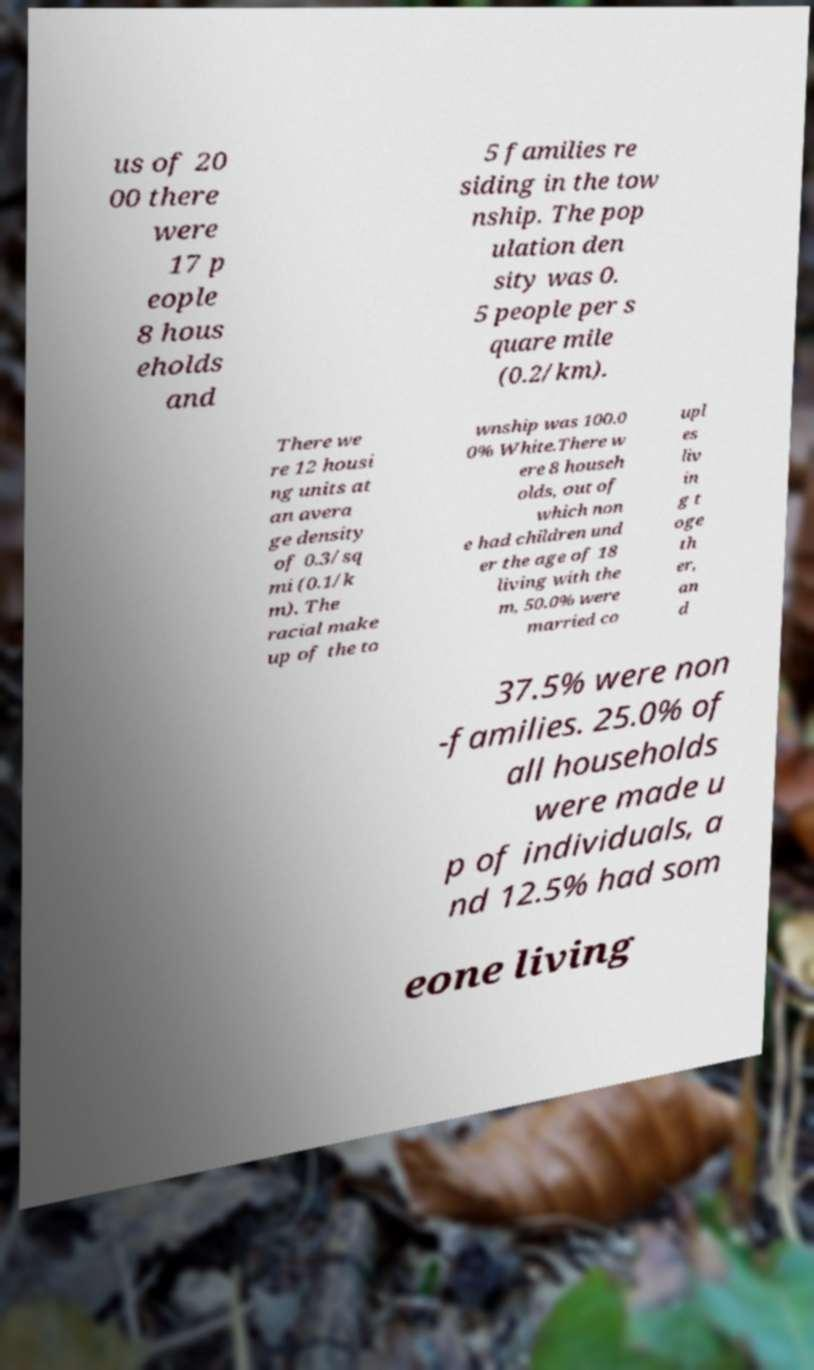Please read and relay the text visible in this image. What does it say? us of 20 00 there were 17 p eople 8 hous eholds and 5 families re siding in the tow nship. The pop ulation den sity was 0. 5 people per s quare mile (0.2/km). There we re 12 housi ng units at an avera ge density of 0.3/sq mi (0.1/k m). The racial make up of the to wnship was 100.0 0% White.There w ere 8 househ olds, out of which non e had children und er the age of 18 living with the m, 50.0% were married co upl es liv in g t oge th er, an d 37.5% were non -families. 25.0% of all households were made u p of individuals, a nd 12.5% had som eone living 